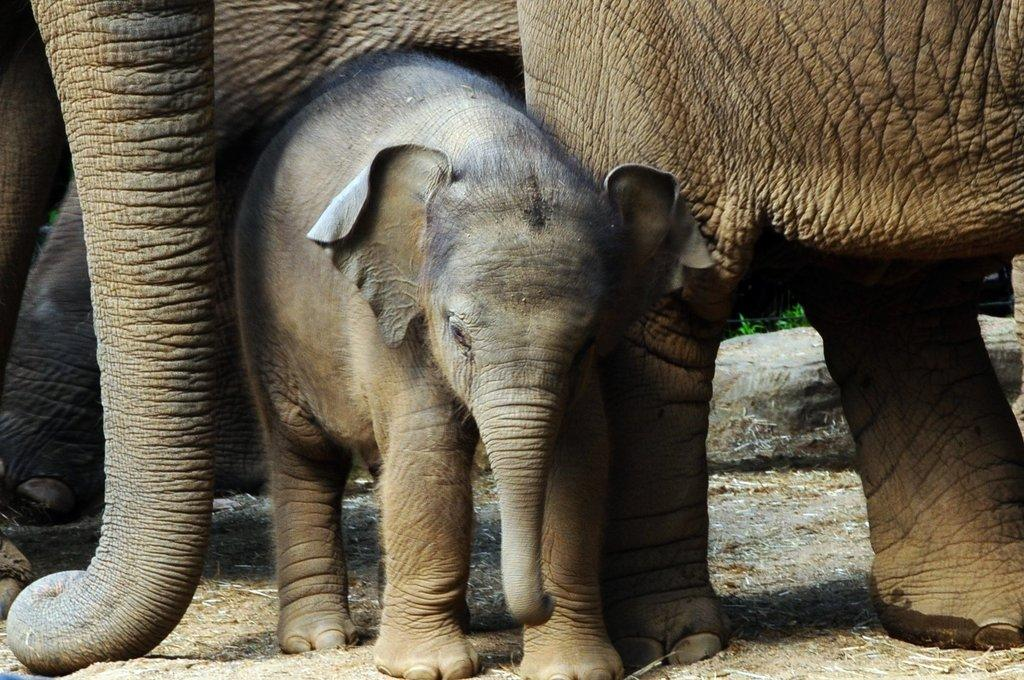What type of animal is the main subject of the image? There is a baby elephant in the image. Are there any other animals of the same species in the image? Yes, there are elephants in the image. What type of terrain is visible at the bottom of the image? There is ground visible at the bottom of the image. How many muscles can be seen in the baby elephant's toes in the image? There is no indication of the number of muscles in the baby elephant's toes in the image, as the image does not focus on the toes or muscles. 